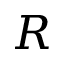<formula> <loc_0><loc_0><loc_500><loc_500>R</formula> 